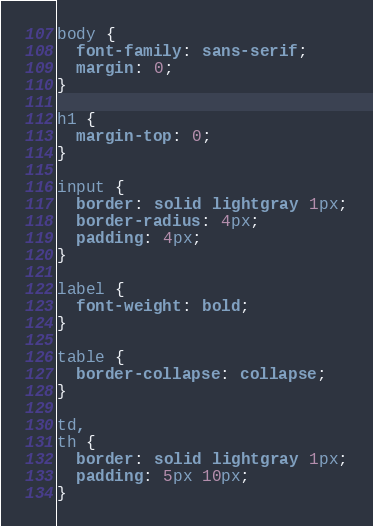Convert code to text. <code><loc_0><loc_0><loc_500><loc_500><_CSS_>body {
  font-family: sans-serif;
  margin: 0;
}

h1 {
  margin-top: 0;
}

input {
  border: solid lightgray 1px;
  border-radius: 4px;
  padding: 4px;
}

label {
  font-weight: bold;
}

table {
  border-collapse: collapse;
}

td,
th {
  border: solid lightgray 1px;
  padding: 5px 10px;
}
</code> 